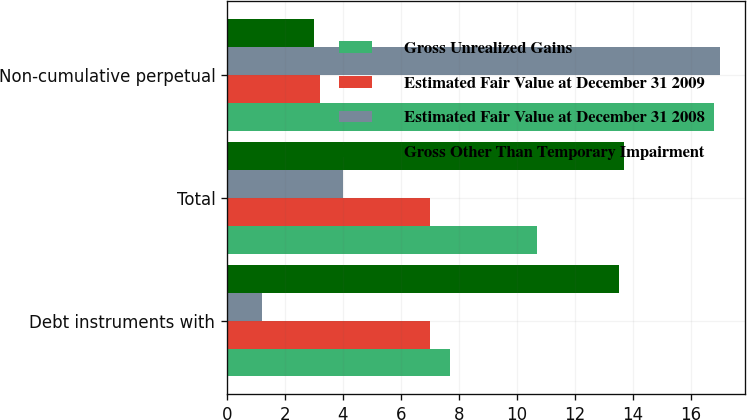Convert chart. <chart><loc_0><loc_0><loc_500><loc_500><stacked_bar_chart><ecel><fcel>Debt instruments with<fcel>Total<fcel>Non-cumulative perpetual<nl><fcel>Gross Unrealized Gains<fcel>7.7<fcel>10.7<fcel>16.8<nl><fcel>Estimated Fair Value at December 31 2009<fcel>7<fcel>7<fcel>3.2<nl><fcel>Estimated Fair Value at December 31 2008<fcel>1.2<fcel>4<fcel>17<nl><fcel>Gross Other Than Temporary Impairment<fcel>13.5<fcel>13.7<fcel>3<nl></chart> 